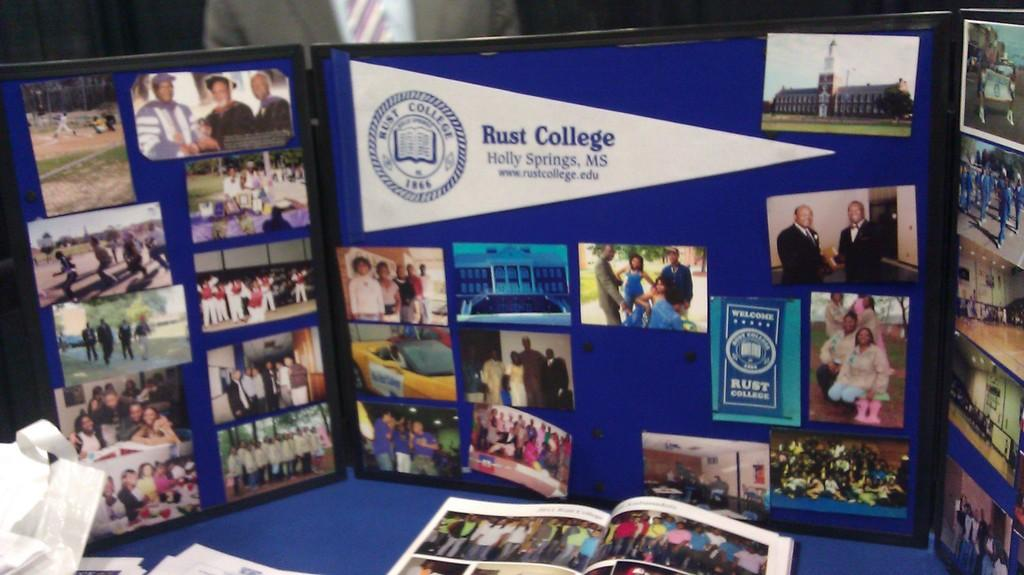<image>
Present a compact description of the photo's key features. A trifold with pictures of people advertising Rust College in Holly Springs, MS. 